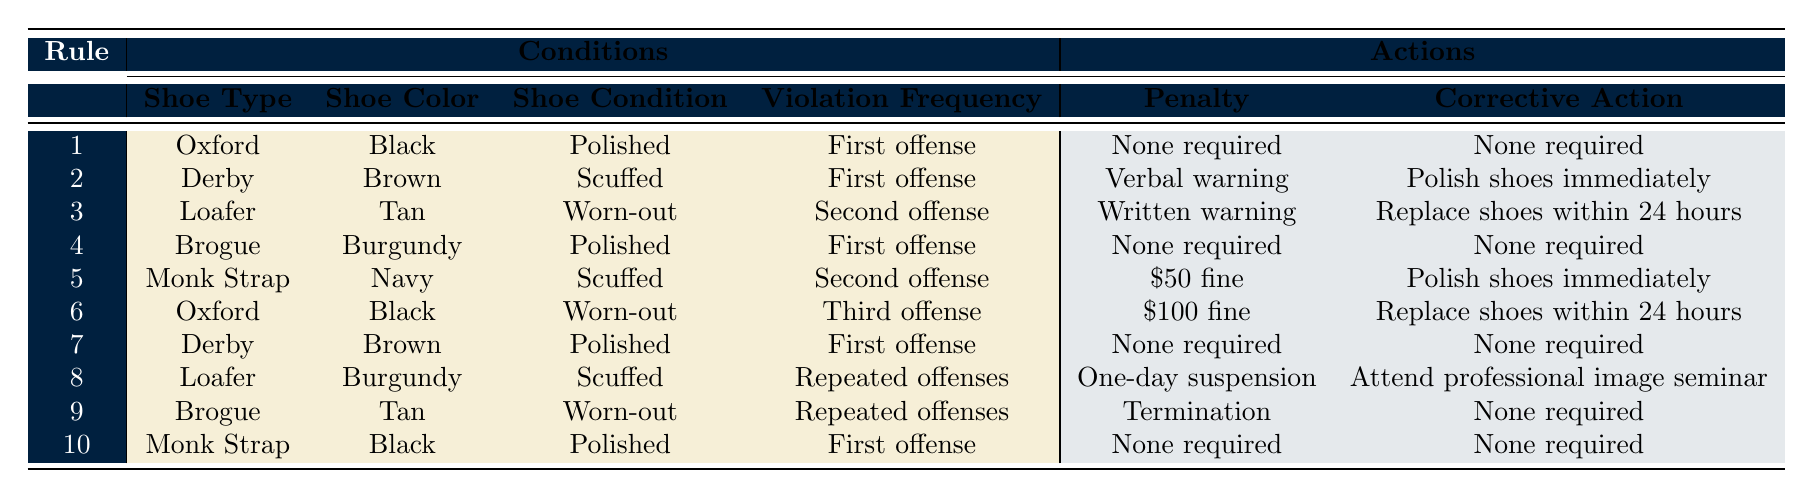What is the penalty for wearing scuffed brown Derby shoes on the first offense? According to the table, the rule indicates that wearing scuffed brown Derby shoes results in a verbal warning and the corrective action is to polish shoes immediately.
Answer: Verbal warning Is there any corrective action required for polished burgundy Brogue shoes on the first offense? The table states that for polished burgundy Brogue shoes on the first offense, no penalty or corrective action is required.
Answer: No What is the sum of penalties for repeated offenses for Loafer shoes in Burgundy and Brogue shoes in Tan? For repeated offenses with Loafer shoes in Burgundy, the penalty is a one-day suspension, and for Brogue shoes in Tan, the penalty is termination. However, since the penalty values are not quantifiable in monetary terms for these actions, your focus must be on understanding the actions instead of numerical sums.
Answer: One-day suspension and termination (not quantifiable) If an employee has a third offense with worn-out black Oxford shoes, what is the penalty? The table shows that for worn-out black Oxford shoes on the third offense, the penalty is a $100 fine, and the corrective action is to replace shoes within 24 hours.
Answer: $100 fine Is there a penalty for first-time offenses with monk strap shoes in navy? The table specifies that for navy monk strap shoes on the first offense, there is no penalty and no corrective action required, meaning the employee is in compliance.
Answer: No 